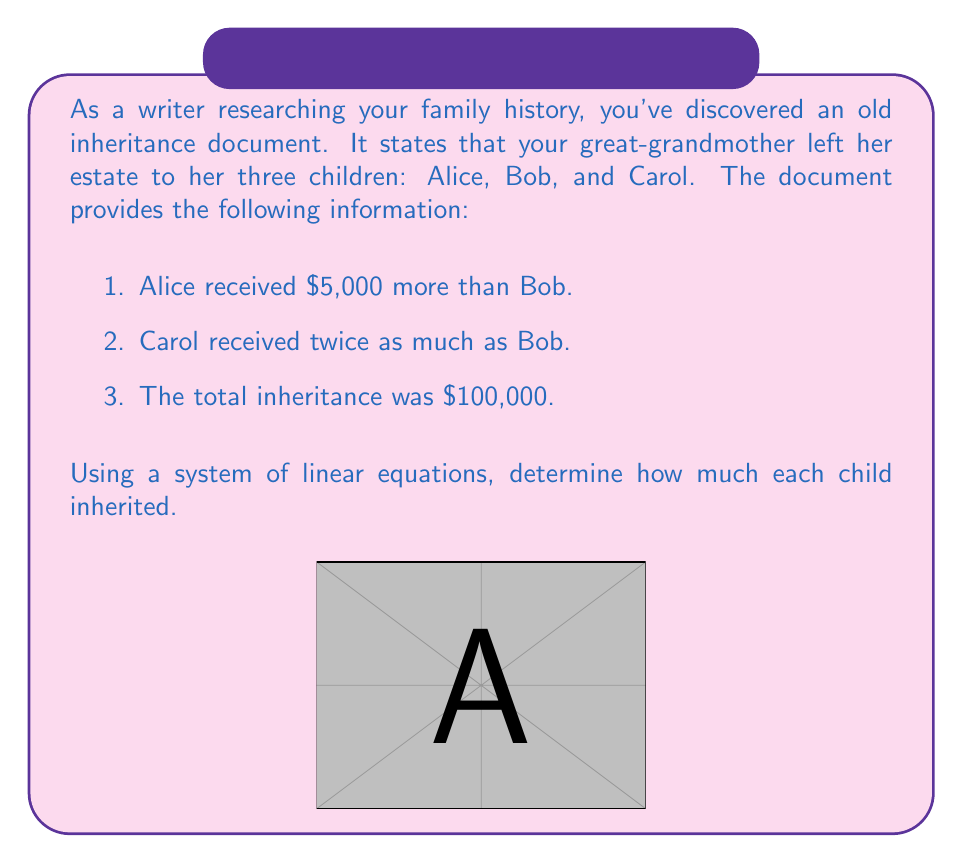Help me with this question. Let's solve this problem step by step using a system of linear equations:

1) Define variables:
   Let $x$ = Bob's inheritance
   Let $y$ = Alice's inheritance
   Let $z$ = Carol's inheritance

2) Set up the system of equations based on the given information:
   $$\begin{cases}
   y = x + 5000 & \text{(Alice received \$5,000 more than Bob)}\\
   z = 2x & \text{(Carol received twice as much as Bob)}\\
   x + y + z = 100000 & \text{(Total inheritance was \$100,000)}
   \end{cases}$$

3) Substitute the expressions for $y$ and $z$ into the third equation:
   $x + (x + 5000) + 2x = 100000$

4) Simplify:
   $4x + 5000 = 100000$

5) Solve for $x$:
   $4x = 95000$
   $x = 23750$

6) Calculate $y$ and $z$:
   $y = x + 5000 = 23750 + 5000 = 28750$
   $z = 2x = 2(23750) = 47500$

7) Verify the total:
   $23750 + 28750 + 47500 = 100000$

Therefore, Bob inherited $23,750, Alice inherited $28,750, and Carol inherited $47,500.
Answer: Bob: $23,750; Alice: $28,750; Carol: $47,500 